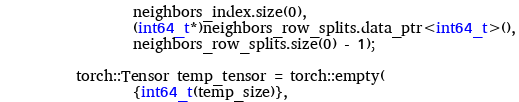Convert code to text. <code><loc_0><loc_0><loc_500><loc_500><_Cuda_>            neighbors_index.size(0),
            (int64_t*)neighbors_row_splits.data_ptr<int64_t>(),
            neighbors_row_splits.size(0) - 1);

    torch::Tensor temp_tensor = torch::empty(
            {int64_t(temp_size)},</code> 